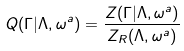<formula> <loc_0><loc_0><loc_500><loc_500>Q ( \Gamma | \Lambda , \omega ^ { a } ) = \frac { Z ( \Gamma | \Lambda , \omega ^ { a } ) } { Z _ { R } ( \Lambda , \omega ^ { a } ) }</formula> 